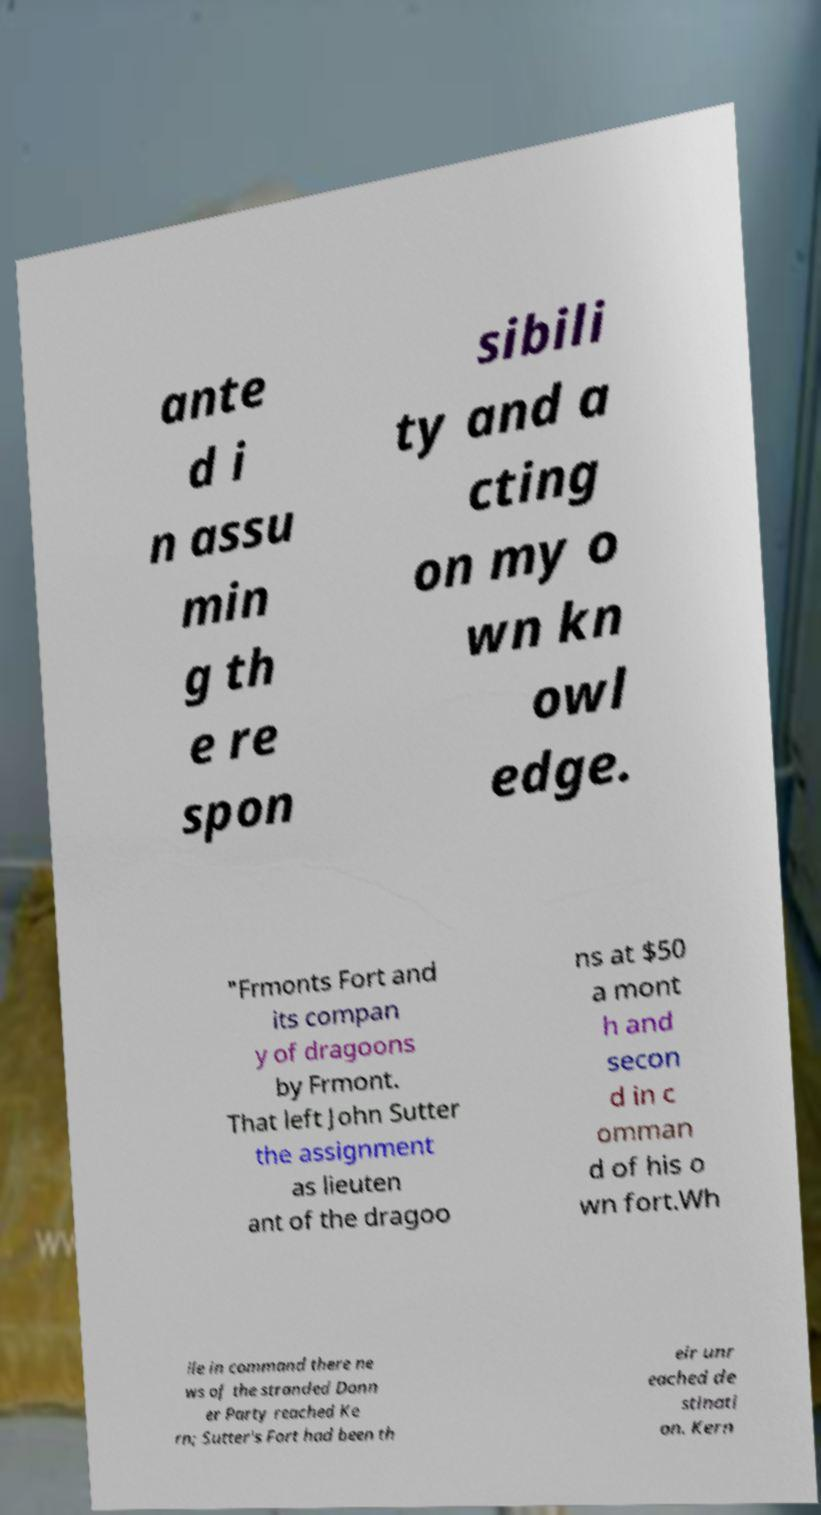Can you read and provide the text displayed in the image?This photo seems to have some interesting text. Can you extract and type it out for me? ante d i n assu min g th e re spon sibili ty and a cting on my o wn kn owl edge. "Frmonts Fort and its compan y of dragoons by Frmont. That left John Sutter the assignment as lieuten ant of the dragoo ns at $50 a mont h and secon d in c omman d of his o wn fort.Wh ile in command there ne ws of the stranded Donn er Party reached Ke rn; Sutter's Fort had been th eir unr eached de stinati on. Kern 